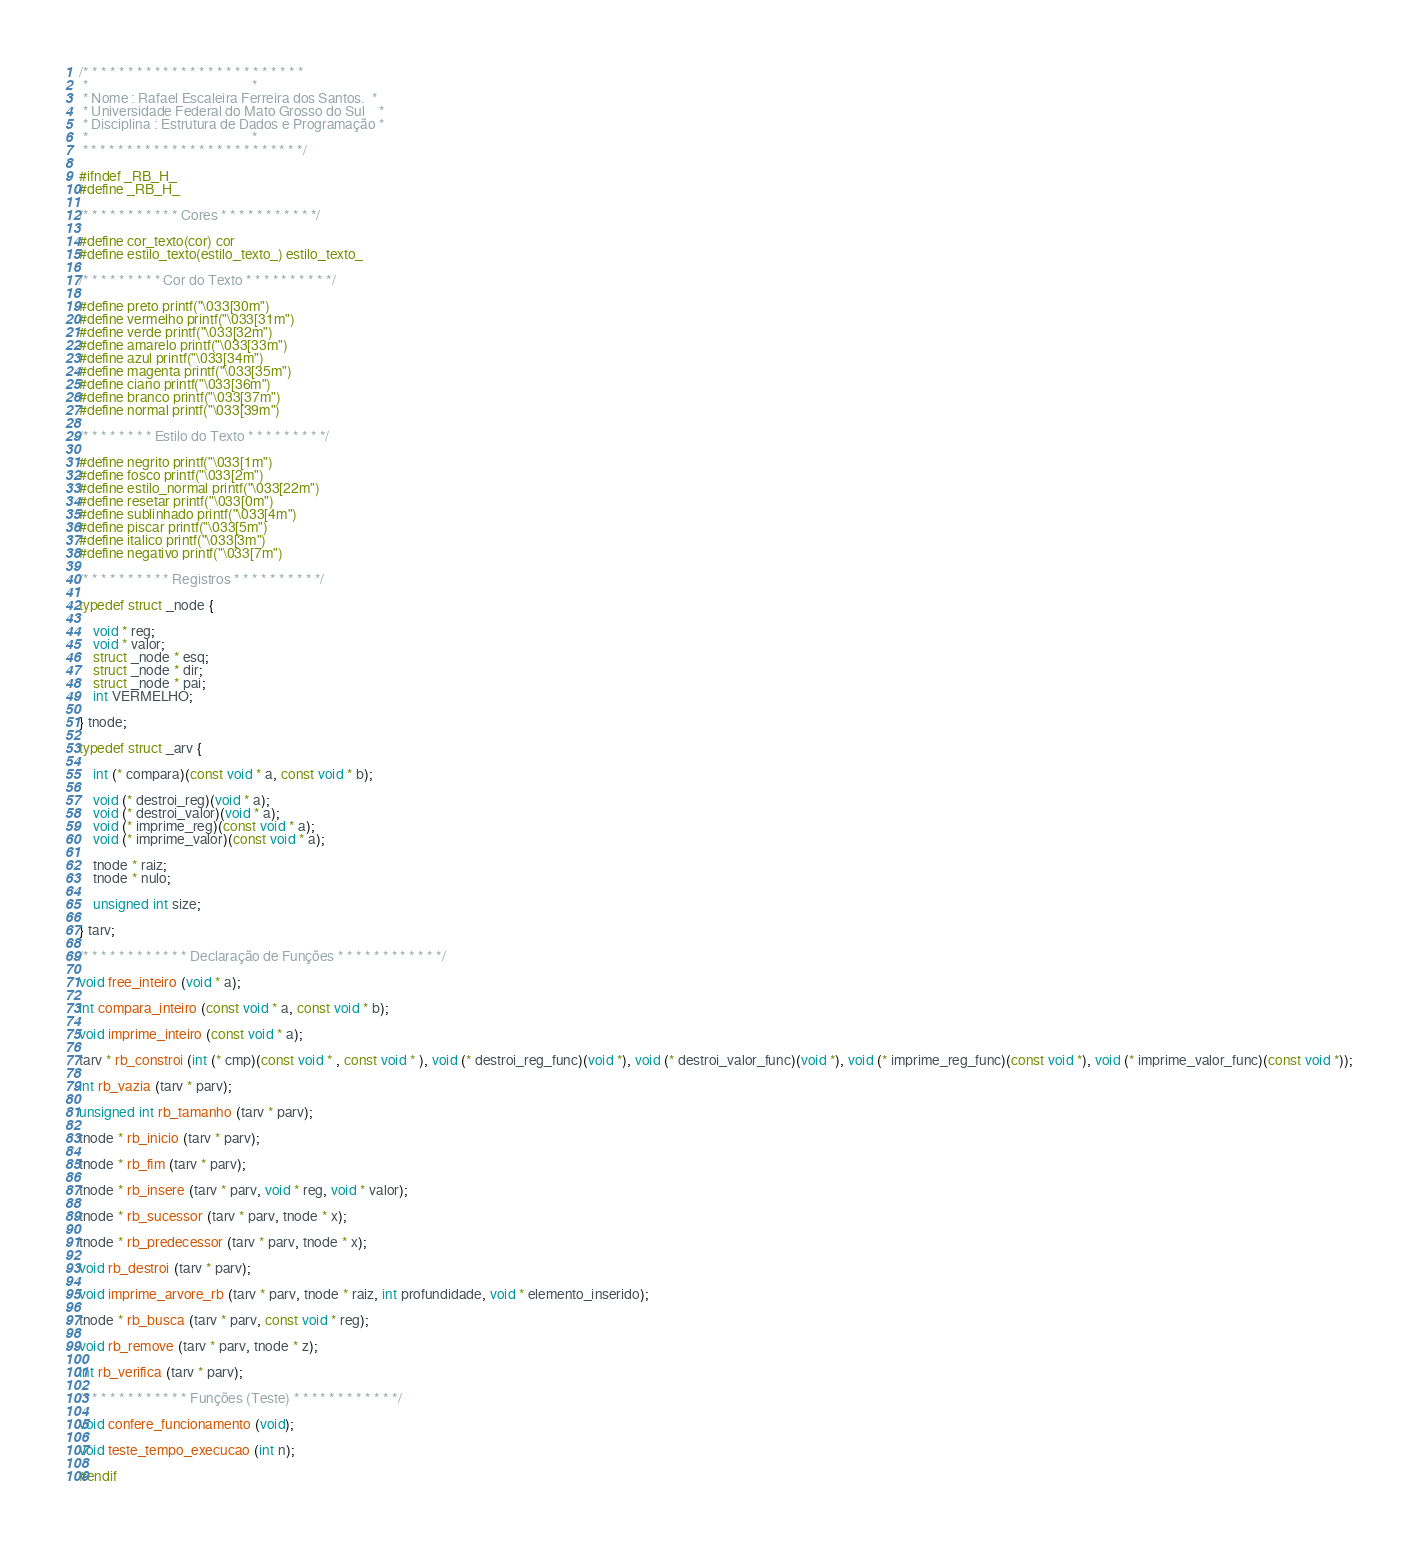Convert code to text. <code><loc_0><loc_0><loc_500><loc_500><_C_>/* * * * * * * * * * * * * * * * * * * * * * * * *
 *                                               *
 * Nome : Rafael Escaleira Ferreira dos Santos.  *
 * Universidade Federal do Mato Grosso do Sul    *
 * Disciplina : Estrutura de Dados e Programação *
 *                                               *
 * * * * * * * * * * * * * * * * * * * * * * * * */

#ifndef _RB_H_
#define _RB_H_

/* * * * * * * * * * * Cores * * * * * * * * * * */

#define cor_texto(cor) cor
#define estilo_texto(estilo_texto_) estilo_texto_

/* * * * * * * * * Cor do Texto * * * * * * * * * */

#define preto printf("\033[30m") 
#define vermelho printf("\033[31m") 
#define verde printf("\033[32m") 
#define amarelo printf("\033[33m") 
#define azul printf("\033[34m") 
#define magenta printf("\033[35m") 
#define ciano printf("\033[36m") 
#define branco printf("\033[37m") 
#define normal printf("\033[39m") 

/* * * * * * * * Estilo do Texto * * * * * * * * */

#define negrito printf("\033[1m")
#define fosco printf("\033[2m")
#define estilo_normal printf("\033[22m")
#define resetar printf("\033[0m")
#define sublinhado printf("\033[4m")
#define piscar printf("\033[5m")
#define italico printf("\033[3m")
#define negativo printf("\033[7m")

/* * * * * * * * * * Registros * * * * * * * * * */

typedef struct _node {

    void * reg;
    void * valor;
    struct _node * esq;
    struct _node * dir;
    struct _node * pai;
    int VERMELHO;

} tnode;

typedef struct _arv {

    int (* compara)(const void * a, const void * b);

    void (* destroi_reg)(void * a);
    void (* destroi_valor)(void * a);
    void (* imprime_reg)(const void * a);
    void (* imprime_valor)(const void * a);

    tnode * raiz;
    tnode * nulo;

    unsigned int size;

} tarv;

/* * * * * * * * * * * * Declaração de Funções * * * * * * * * * * * */

void free_inteiro (void * a);

int compara_inteiro (const void * a, const void * b);

void imprime_inteiro (const void * a);

tarv * rb_constroi (int (* cmp)(const void * , const void * ), void (* destroi_reg_func)(void *), void (* destroi_valor_func)(void *), void (* imprime_reg_func)(const void *), void (* imprime_valor_func)(const void *));

int rb_vazia (tarv * parv);

unsigned int rb_tamanho (tarv * parv);

tnode * rb_inicio (tarv * parv);

tnode * rb_fim (tarv * parv);

tnode * rb_insere (tarv * parv, void * reg, void * valor);

tnode * rb_sucessor (tarv * parv, tnode * x);

tnode * rb_predecessor (tarv * parv, tnode * x);

void rb_destroi (tarv * parv);

void imprime_arvore_rb (tarv * parv, tnode * raiz, int profundidade, void * elemento_inserido);

tnode * rb_busca (tarv * parv, const void * reg);

void rb_remove (tarv * parv, tnode * z);

int rb_verifica (tarv * parv);

/* * * * * * * * * * * * Funções (Teste) * * * * * * * * * * * */

void confere_funcionamento (void);

void teste_tempo_execucao (int n);

#endif
</code> 